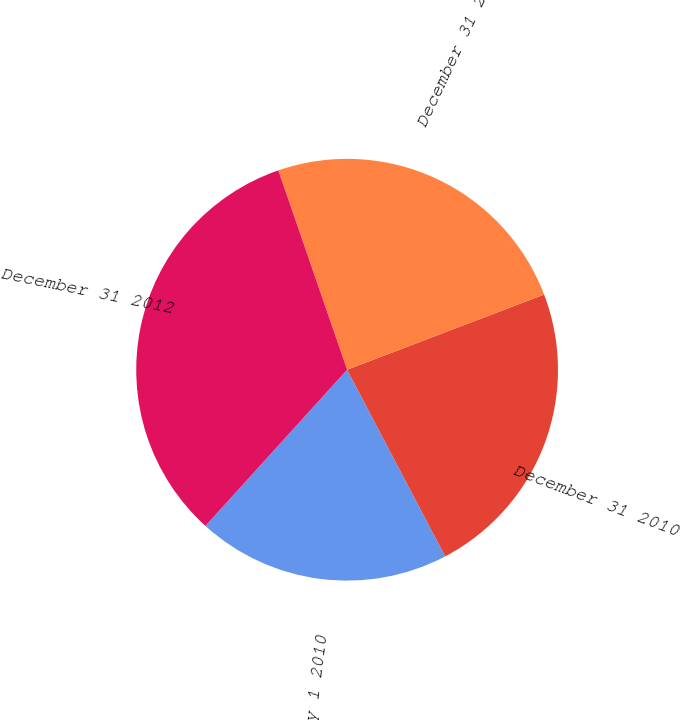Convert chart. <chart><loc_0><loc_0><loc_500><loc_500><pie_chart><fcel>January 1 2010<fcel>December 31 2010<fcel>December 31 2011<fcel>December 31 2012<nl><fcel>19.43%<fcel>23.1%<fcel>24.49%<fcel>32.99%<nl></chart> 